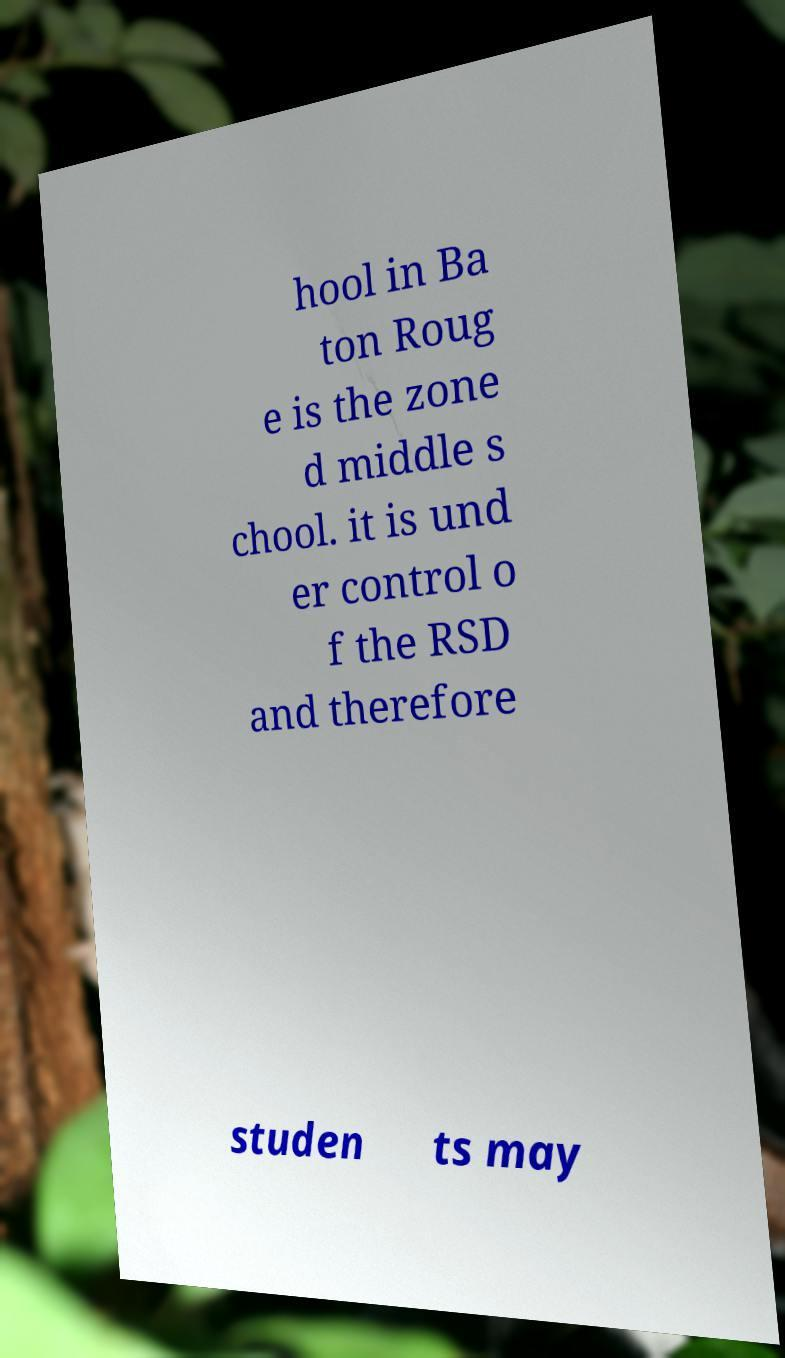There's text embedded in this image that I need extracted. Can you transcribe it verbatim? hool in Ba ton Roug e is the zone d middle s chool. it is und er control o f the RSD and therefore studen ts may 